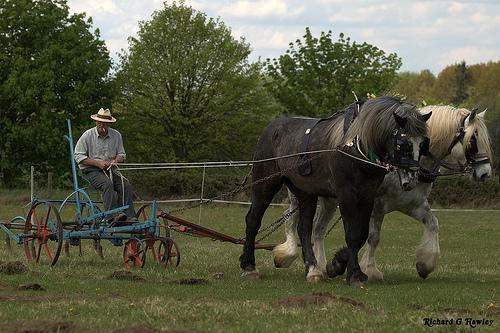How many people are pictured?
Give a very brief answer. 1. 